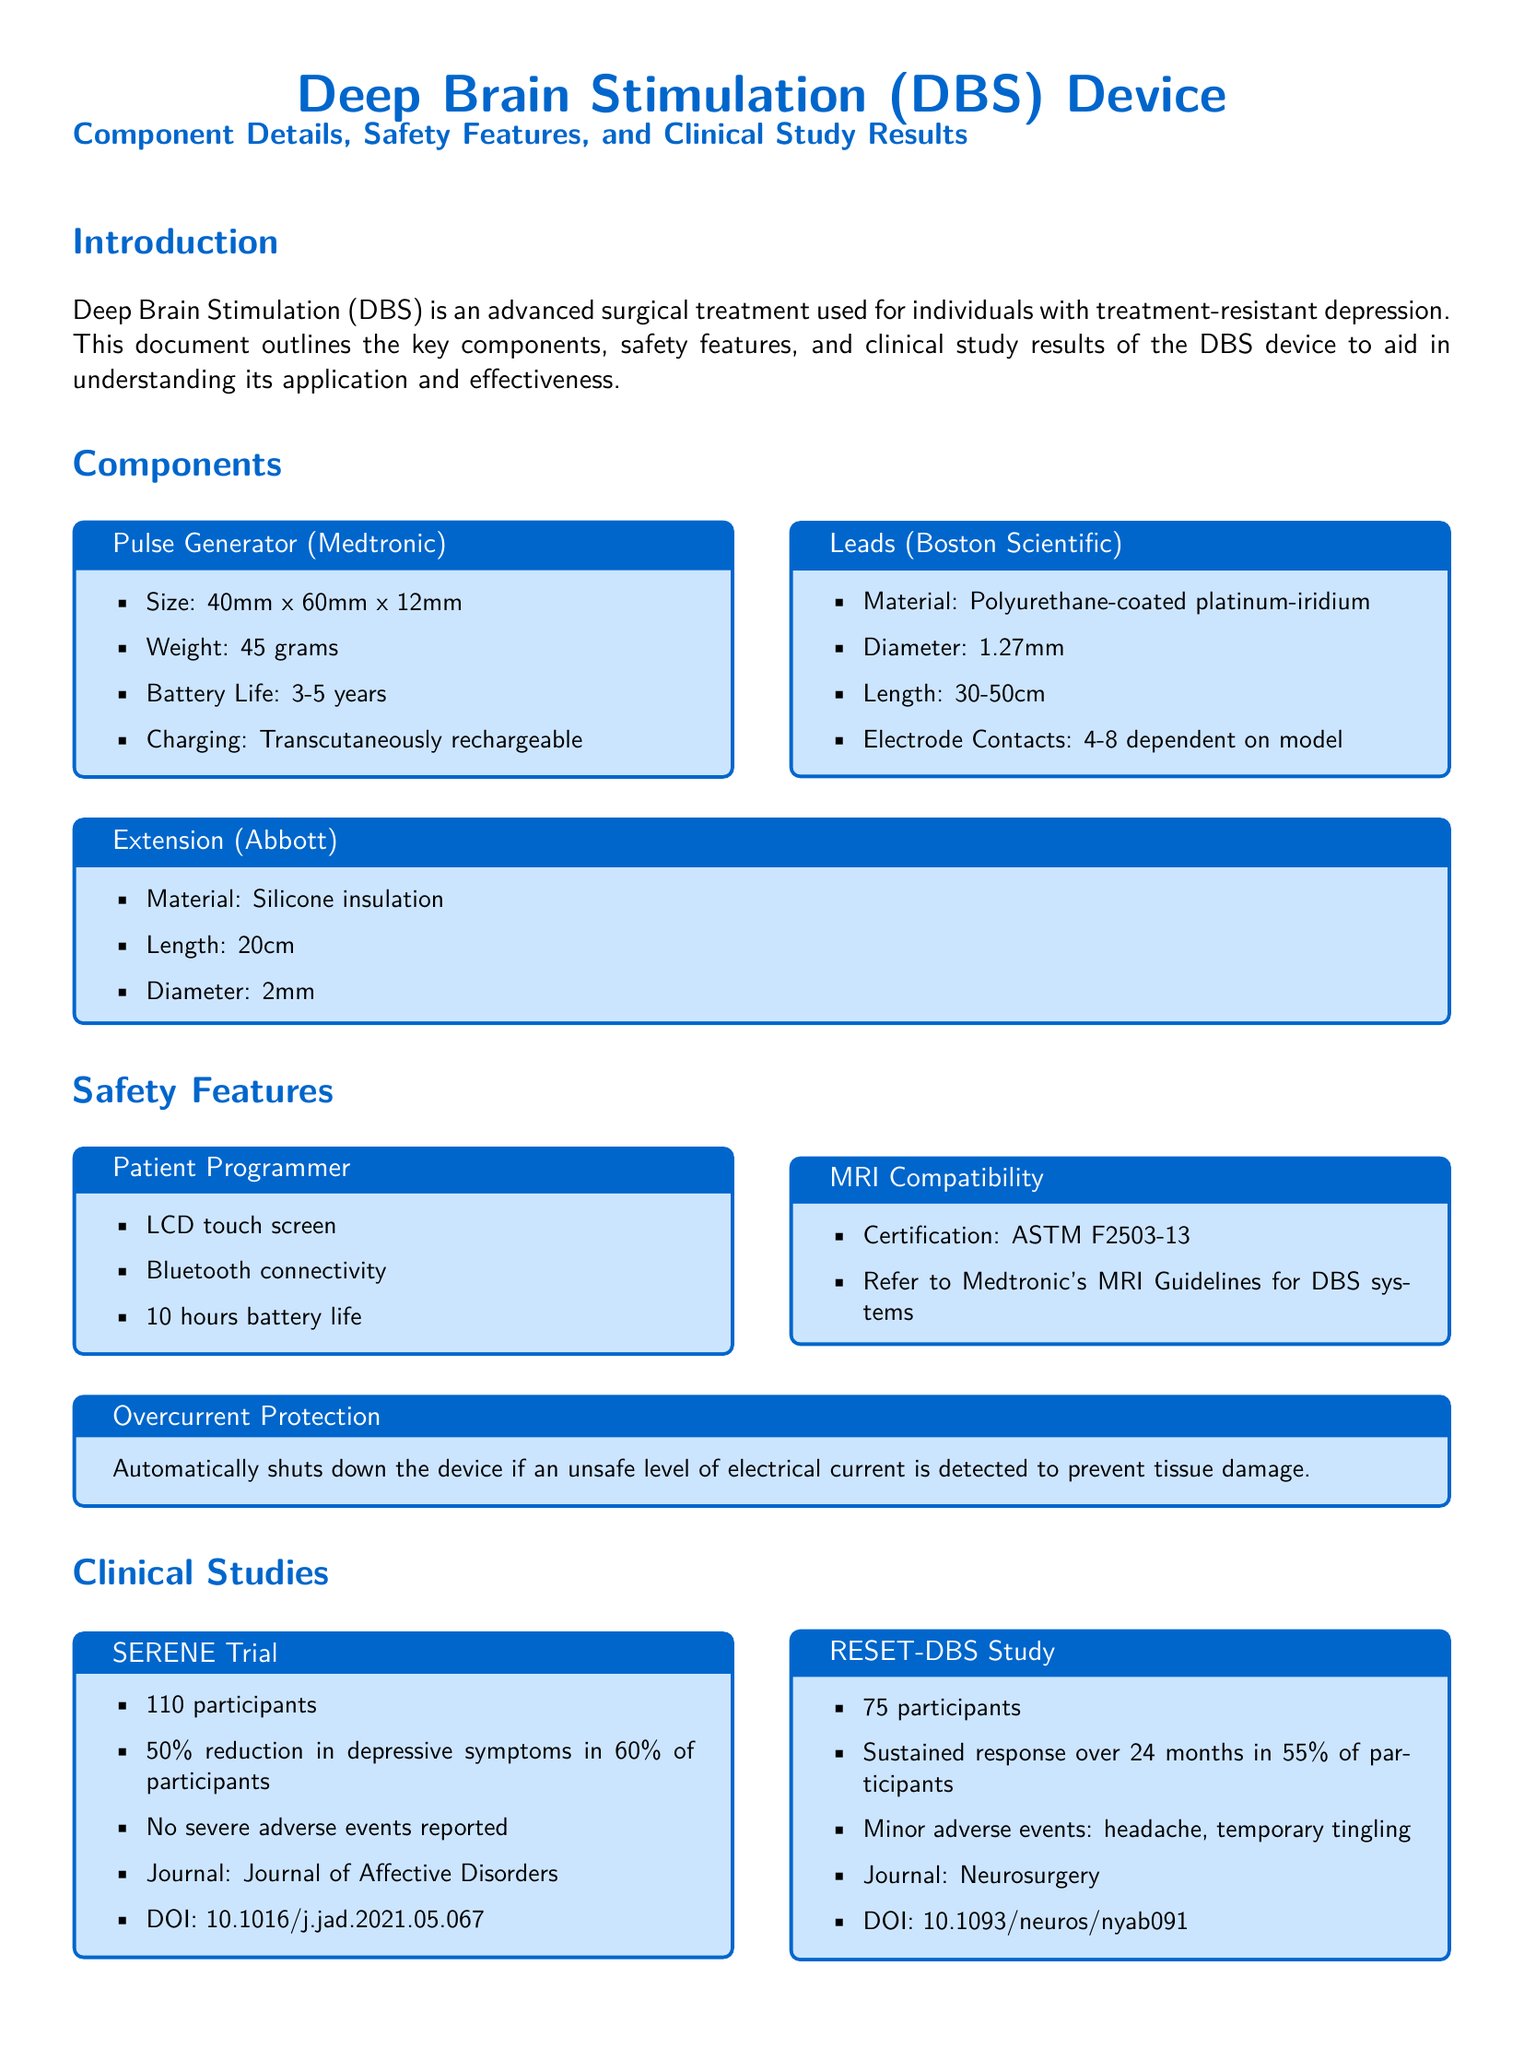what is the size of the Pulse Generator? The size of the Pulse Generator is specified as 40mm x 60mm x 12mm.
Answer: 40mm x 60mm x 12mm how long is the Extension cable? The length of the Extension is stated as 20cm.
Answer: 20cm how many participants were in the SERENE Trial? The SERENE Trial involved 110 participants.
Answer: 110 participants what is the battery life of the Patient Programmer? The battery life of the Patient Programmer is mentioned to be 10 hours.
Answer: 10 hours what percentage of participants reported a 50% reduction in depressive symptoms in the SERENE Trial? The document notes that 60% of participants experienced a 50% reduction in symptoms.
Answer: 60% what safety feature automatically shuts down the device? The Overcurrent Protection feature is designed to automatically shut down the device.
Answer: Overcurrent Protection what was the sustained response rate over 24 months in the RESET-DBS Study? The sustained response rate in the RESET-DBS Study was 55% over 24 months.
Answer: 55% which journal published the results of the SERENE Trial? The results of the SERENE Trial were published in the Journal of Affective Disorders.
Answer: Journal of Affective Disorders what is the material used for the leads? The leads are made of polyurethane-coated platinum-iridium.
Answer: polyurethane-coated platinum-iridium 